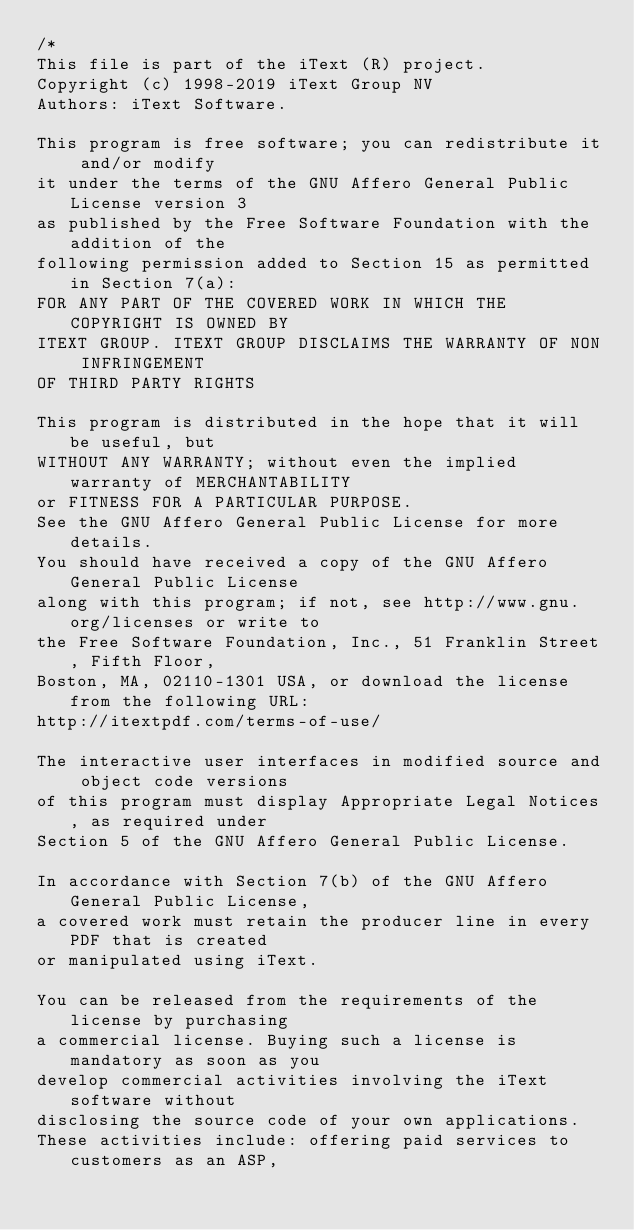<code> <loc_0><loc_0><loc_500><loc_500><_C#_>/*
This file is part of the iText (R) project.
Copyright (c) 1998-2019 iText Group NV
Authors: iText Software.

This program is free software; you can redistribute it and/or modify
it under the terms of the GNU Affero General Public License version 3
as published by the Free Software Foundation with the addition of the
following permission added to Section 15 as permitted in Section 7(a):
FOR ANY PART OF THE COVERED WORK IN WHICH THE COPYRIGHT IS OWNED BY
ITEXT GROUP. ITEXT GROUP DISCLAIMS THE WARRANTY OF NON INFRINGEMENT
OF THIRD PARTY RIGHTS

This program is distributed in the hope that it will be useful, but
WITHOUT ANY WARRANTY; without even the implied warranty of MERCHANTABILITY
or FITNESS FOR A PARTICULAR PURPOSE.
See the GNU Affero General Public License for more details.
You should have received a copy of the GNU Affero General Public License
along with this program; if not, see http://www.gnu.org/licenses or write to
the Free Software Foundation, Inc., 51 Franklin Street, Fifth Floor,
Boston, MA, 02110-1301 USA, or download the license from the following URL:
http://itextpdf.com/terms-of-use/

The interactive user interfaces in modified source and object code versions
of this program must display Appropriate Legal Notices, as required under
Section 5 of the GNU Affero General Public License.

In accordance with Section 7(b) of the GNU Affero General Public License,
a covered work must retain the producer line in every PDF that is created
or manipulated using iText.

You can be released from the requirements of the license by purchasing
a commercial license. Buying such a license is mandatory as soon as you
develop commercial activities involving the iText software without
disclosing the source code of your own applications.
These activities include: offering paid services to customers as an ASP,</code> 